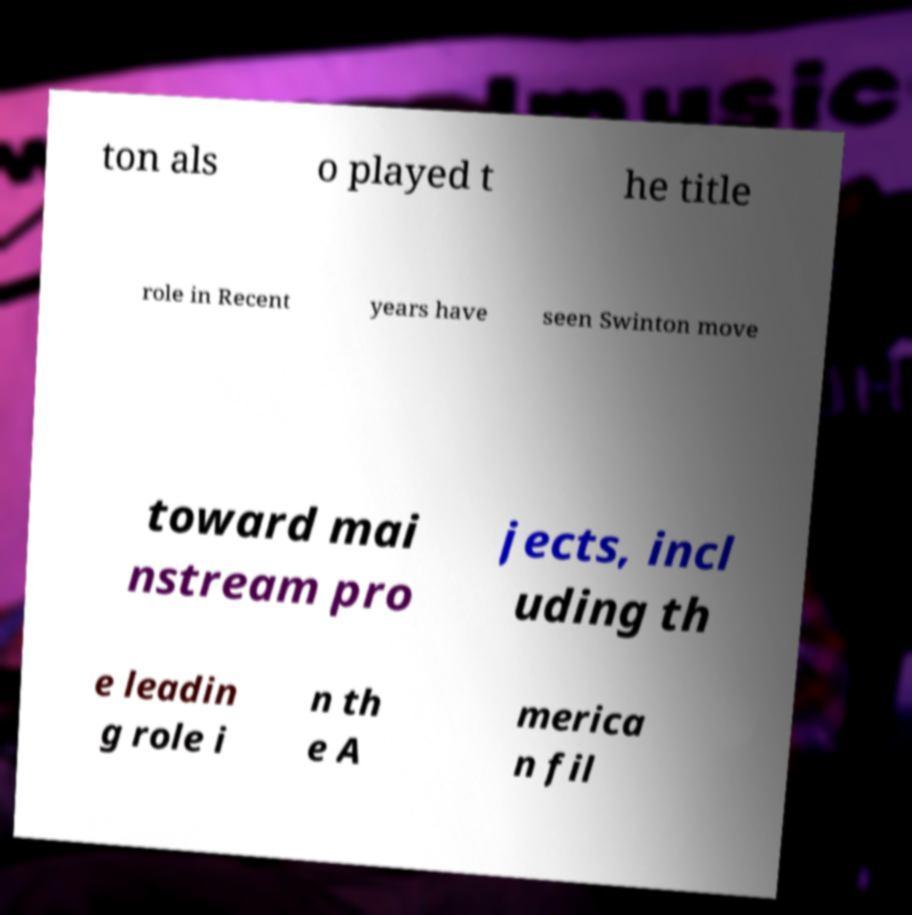Please identify and transcribe the text found in this image. ton als o played t he title role in Recent years have seen Swinton move toward mai nstream pro jects, incl uding th e leadin g role i n th e A merica n fil 